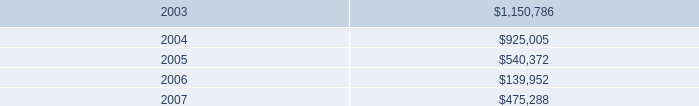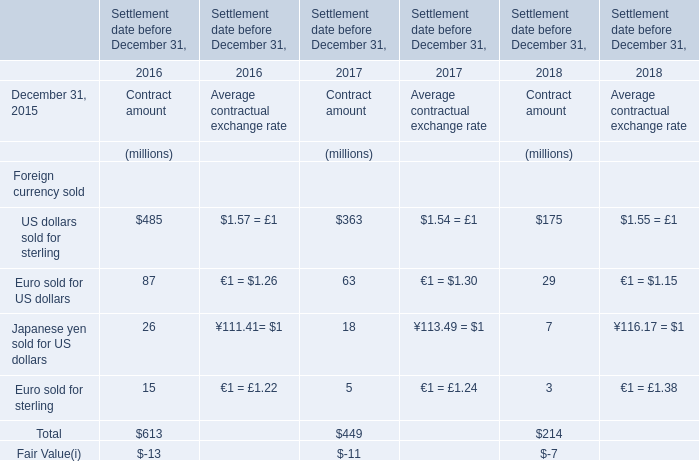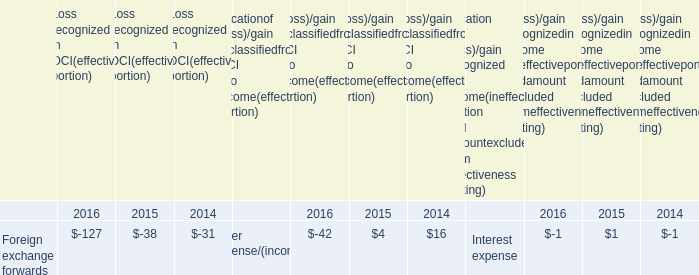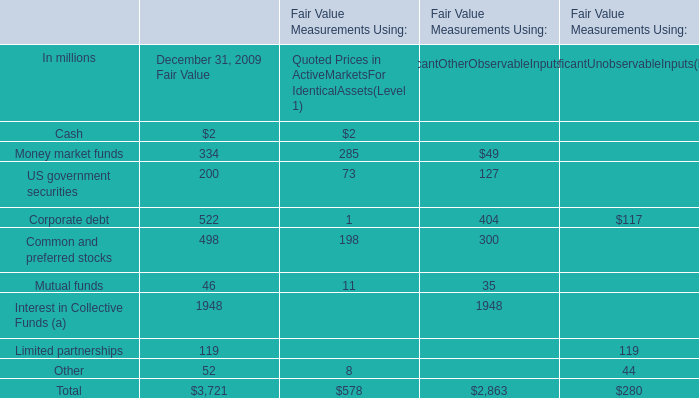what was the sum of the notes entergy issued to nypa with seven and eight annual payment installments 
Computations: ((20 * 8) + (108 * 7))
Answer: 916.0. 